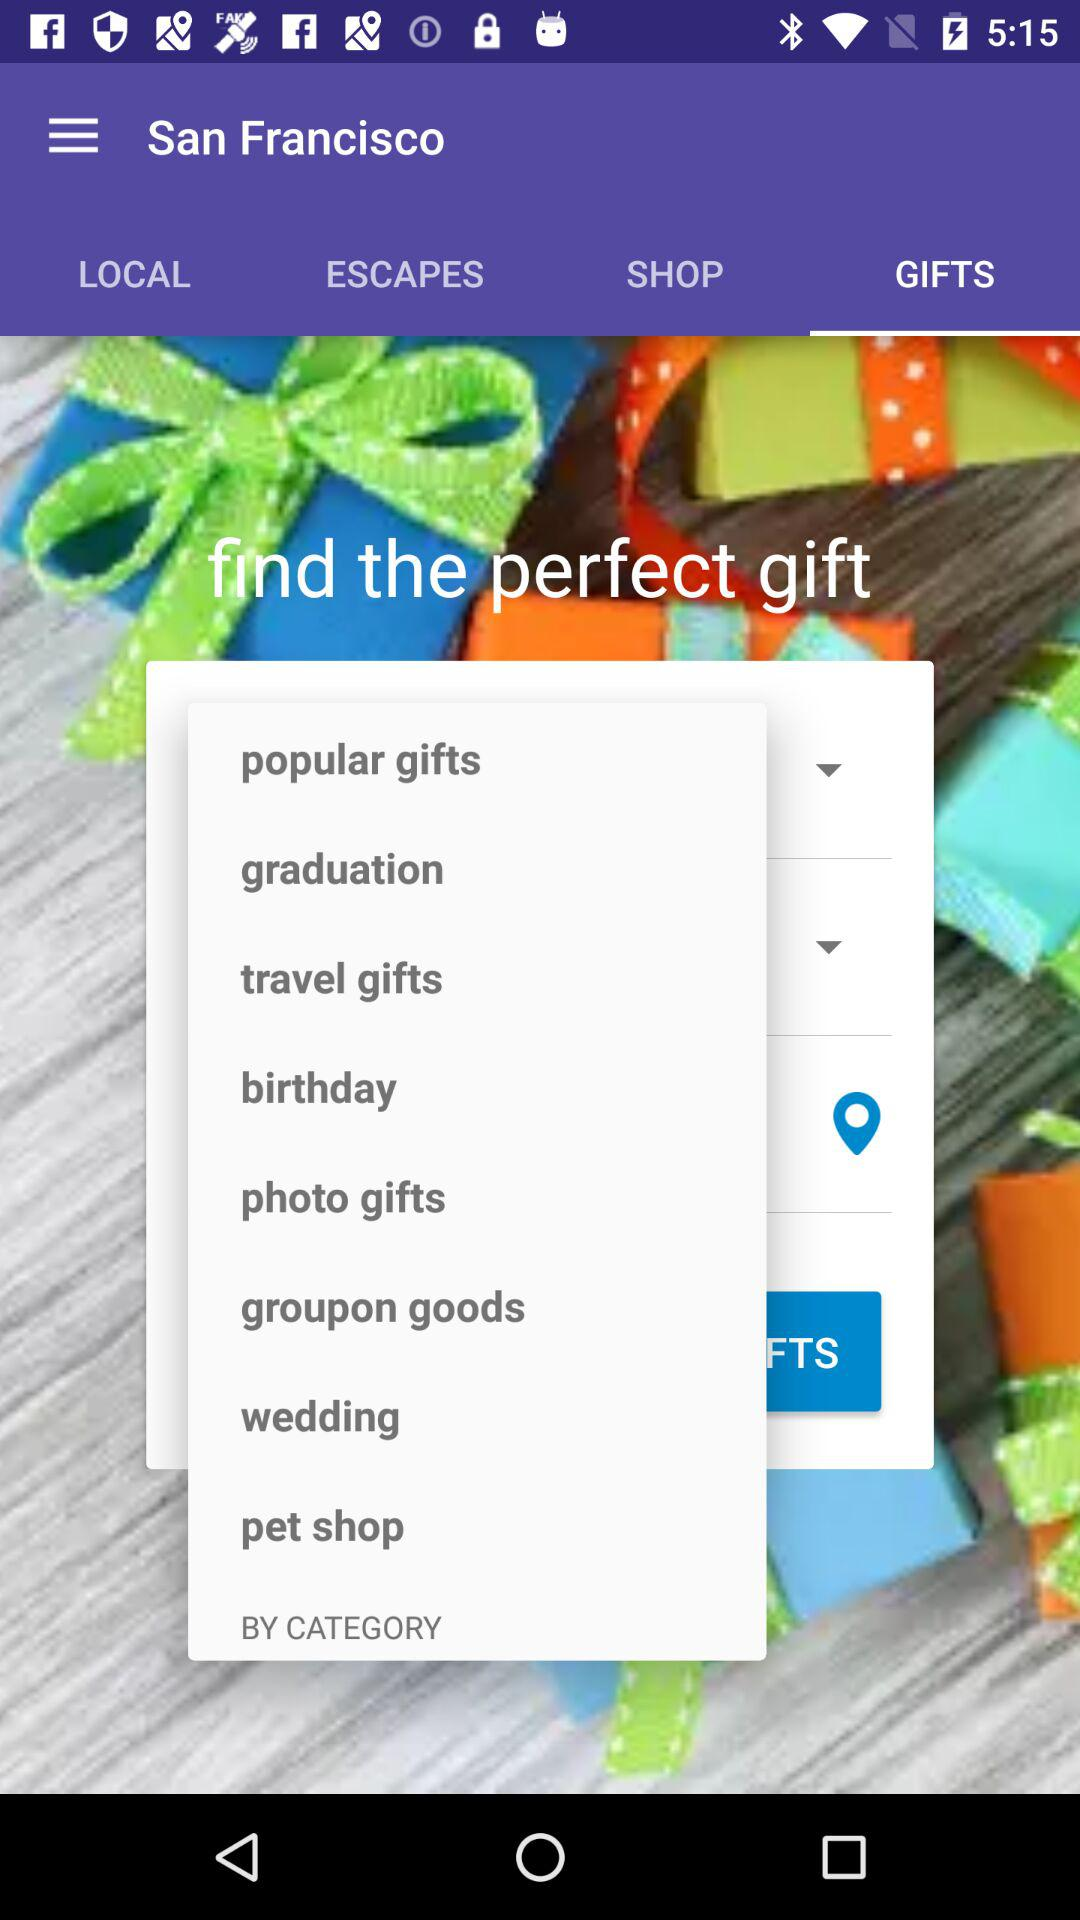What is the location? The location is San Francisco. 